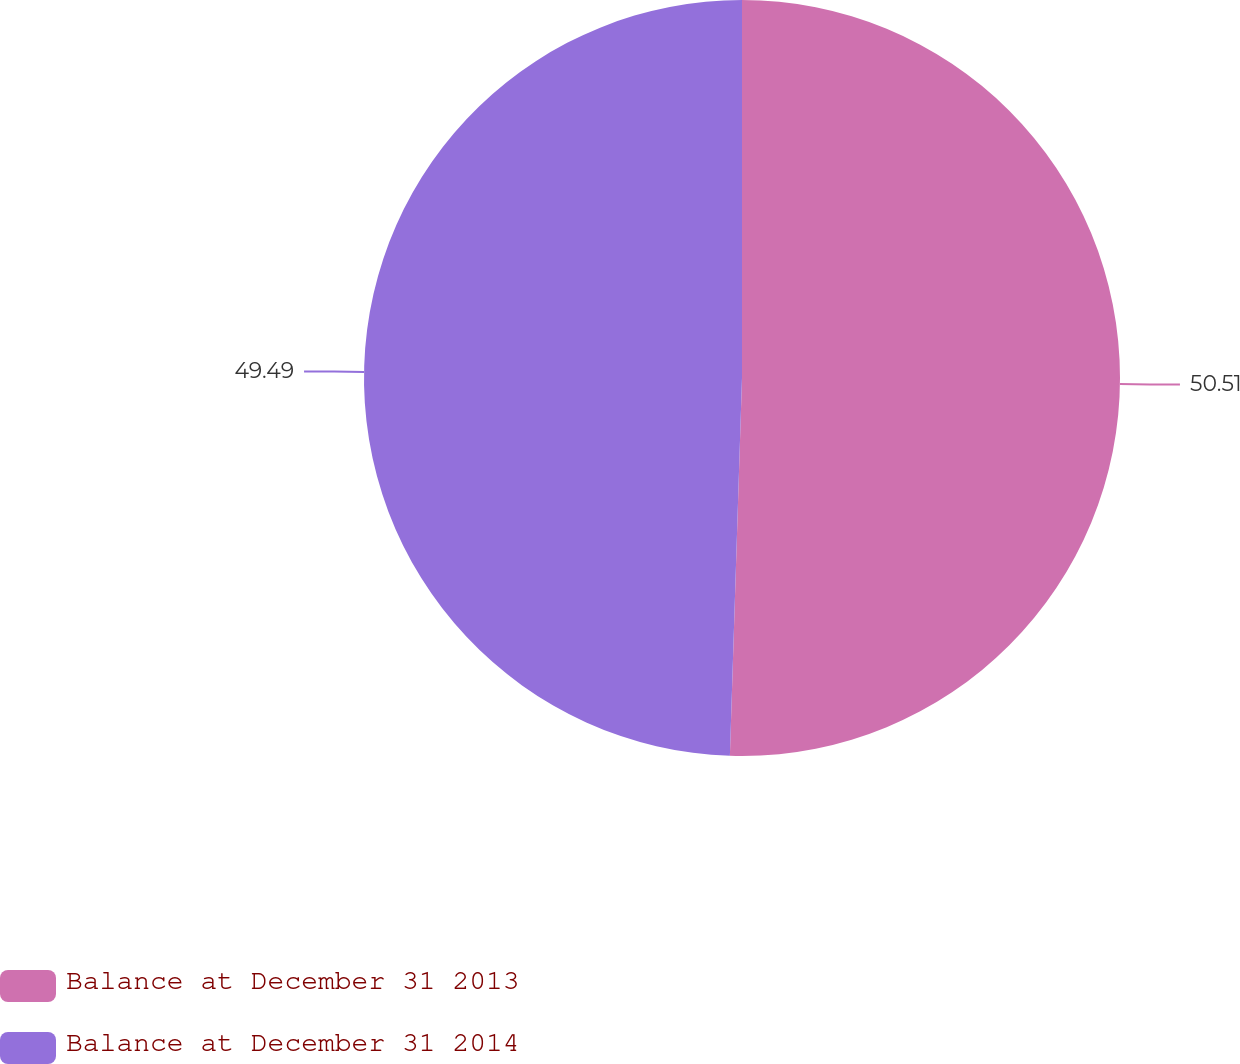Convert chart. <chart><loc_0><loc_0><loc_500><loc_500><pie_chart><fcel>Balance at December 31 2013<fcel>Balance at December 31 2014<nl><fcel>50.51%<fcel>49.49%<nl></chart> 